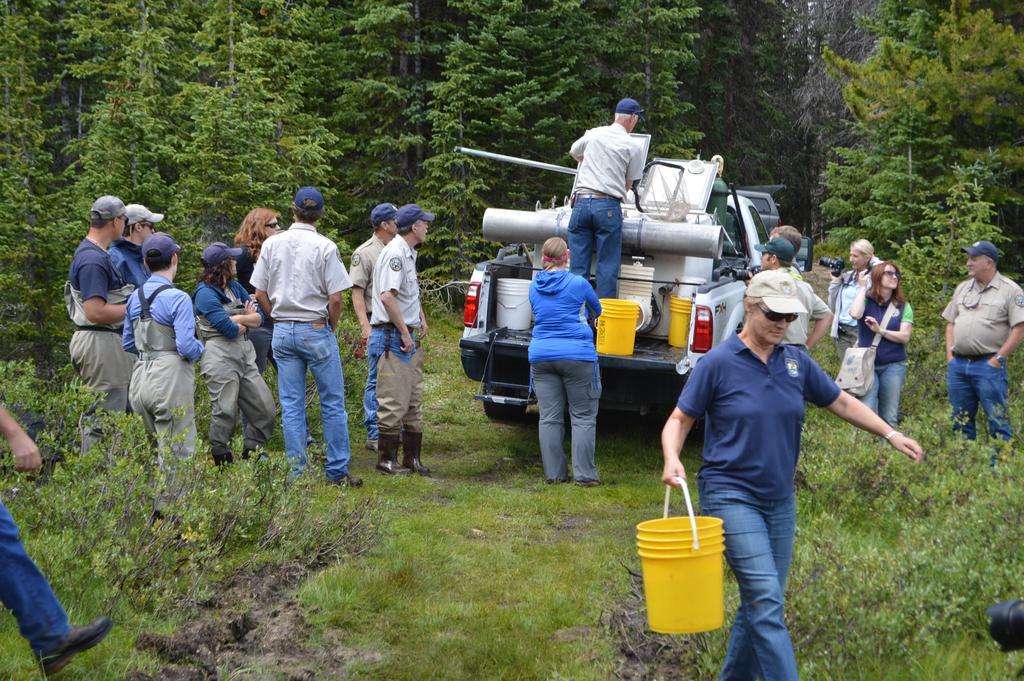Could you give a brief overview of what you see in this image? In this picture I can see a person standing and holding a basket, there are group of people standing, there are buckets on the vehicle, and in the background there are trees. 